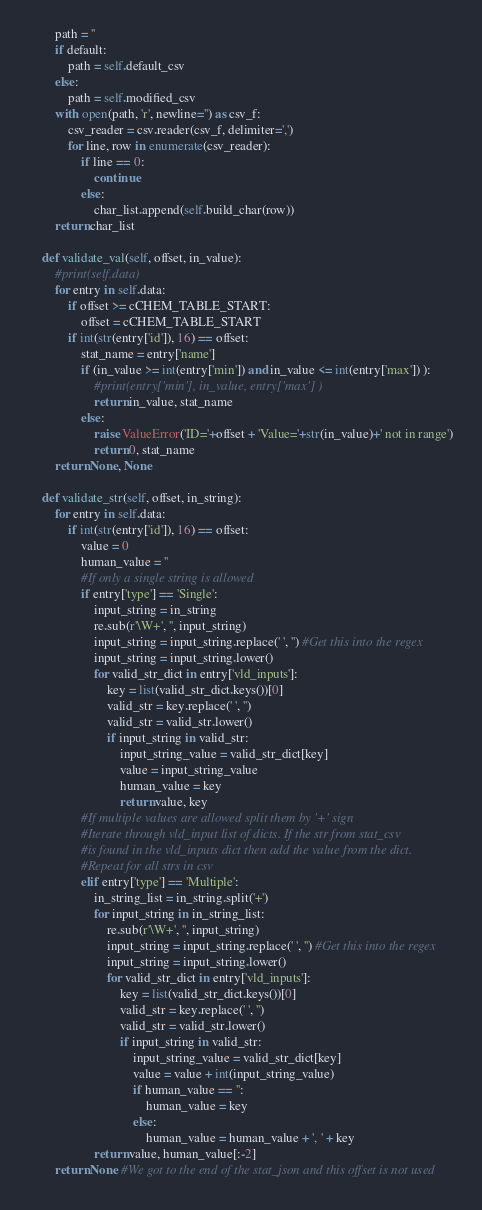<code> <loc_0><loc_0><loc_500><loc_500><_Python_>        path = ''
        if default:
            path = self.default_csv
        else:
            path = self.modified_csv
        with open(path, 'r', newline='') as csv_f:
            csv_reader = csv.reader(csv_f, delimiter=',')
            for line, row in enumerate(csv_reader):
                if line == 0:
                    continue
                else:
                    char_list.append(self.build_char(row))
        return char_list
                        
    def validate_val(self, offset, in_value):
        #print(self.data)
        for entry in self.data:
            if offset >= cCHEM_TABLE_START:
                offset = cCHEM_TABLE_START
            if int(str(entry['id']), 16) == offset:
                stat_name = entry['name']
                if (in_value >= int(entry['min']) and in_value <= int(entry['max']) ):
                    #print(entry['min'], in_value, entry['max'] )
                    return in_value, stat_name
                else:
                    raise ValueError('ID='+offset + 'Value='+str(in_value)+' not in range')
                    return 0, stat_name
        return None, None

    def validate_str(self, offset, in_string):
        for entry in self.data:
            if int(str(entry['id']), 16) == offset:
                value = 0
                human_value = ''
                #If only a single string is allowed
                if entry['type'] == 'Single':
                    input_string = in_string
                    re.sub(r'\W+', '', input_string)
                    input_string = input_string.replace(' ', '') #Get this into the regex
                    input_string = input_string.lower()
                    for valid_str_dict in entry['vld_inputs']:
                        key = list(valid_str_dict.keys())[0]
                        valid_str = key.replace(' ', '')
                        valid_str = valid_str.lower()
                        if input_string in valid_str:
                            input_string_value = valid_str_dict[key]
                            value = input_string_value
                            human_value = key
                            return value, key
                #If multiple values are allowed split them by '+' sign
                #Iterate through vld_input list of dicts. If the str from stat_csv 
                #is found in the vld_inputs dict then add the value from the dict.
                #Repeat for all strs in csv 
                elif entry['type'] == 'Multiple':
                    in_string_list = in_string.split('+')
                    for input_string in in_string_list:
                        re.sub(r'\W+', '', input_string)
                        input_string = input_string.replace(' ', '') #Get this into the regex
                        input_string = input_string.lower()
                        for valid_str_dict in entry['vld_inputs']:
                            key = list(valid_str_dict.keys())[0]
                            valid_str = key.replace(' ', '')
                            valid_str = valid_str.lower()
                            if input_string in valid_str:
                                input_string_value = valid_str_dict[key]
                                value = value + int(input_string_value)
                                if human_value == '':
                                    human_value = key
                                else:
                                    human_value = human_value + ', ' + key
                    return value, human_value[:-2]
        return None #We got to the end of the stat_json and this offset is not used

</code> 